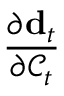<formula> <loc_0><loc_0><loc_500><loc_500>\frac { \partial d _ { t } } { \partial \mathcal { C } _ { t } }</formula> 